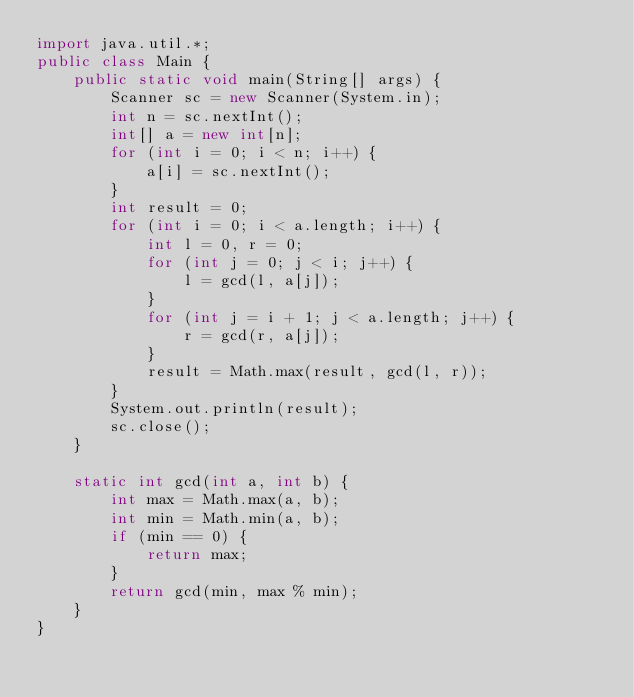<code> <loc_0><loc_0><loc_500><loc_500><_Java_>import java.util.*;
public class Main {
    public static void main(String[] args) {
        Scanner sc = new Scanner(System.in);
        int n = sc.nextInt();
        int[] a = new int[n];
        for (int i = 0; i < n; i++) {
            a[i] = sc.nextInt();
        }
        int result = 0;
        for (int i = 0; i < a.length; i++) {
            int l = 0, r = 0;
            for (int j = 0; j < i; j++) {
                l = gcd(l, a[j]);
            }
            for (int j = i + 1; j < a.length; j++) {
                r = gcd(r, a[j]);
            }
            result = Math.max(result, gcd(l, r));
        }
        System.out.println(result);
        sc.close();
    }

    static int gcd(int a, int b) {
        int max = Math.max(a, b);
        int min = Math.min(a, b);
        if (min == 0) {
            return max;
        }
        return gcd(min, max % min);
    }
}</code> 